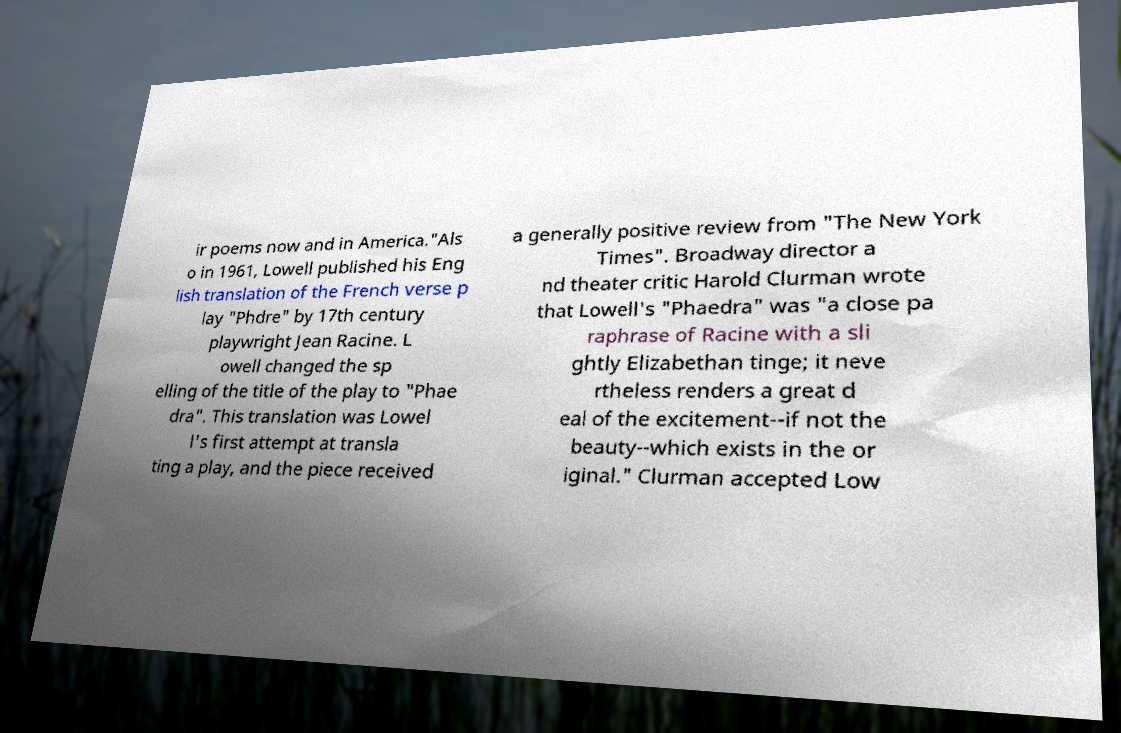I need the written content from this picture converted into text. Can you do that? ir poems now and in America."Als o in 1961, Lowell published his Eng lish translation of the French verse p lay "Phdre" by 17th century playwright Jean Racine. L owell changed the sp elling of the title of the play to "Phae dra". This translation was Lowel l's first attempt at transla ting a play, and the piece received a generally positive review from "The New York Times". Broadway director a nd theater critic Harold Clurman wrote that Lowell's "Phaedra" was "a close pa raphrase of Racine with a sli ghtly Elizabethan tinge; it neve rtheless renders a great d eal of the excitement--if not the beauty--which exists in the or iginal." Clurman accepted Low 